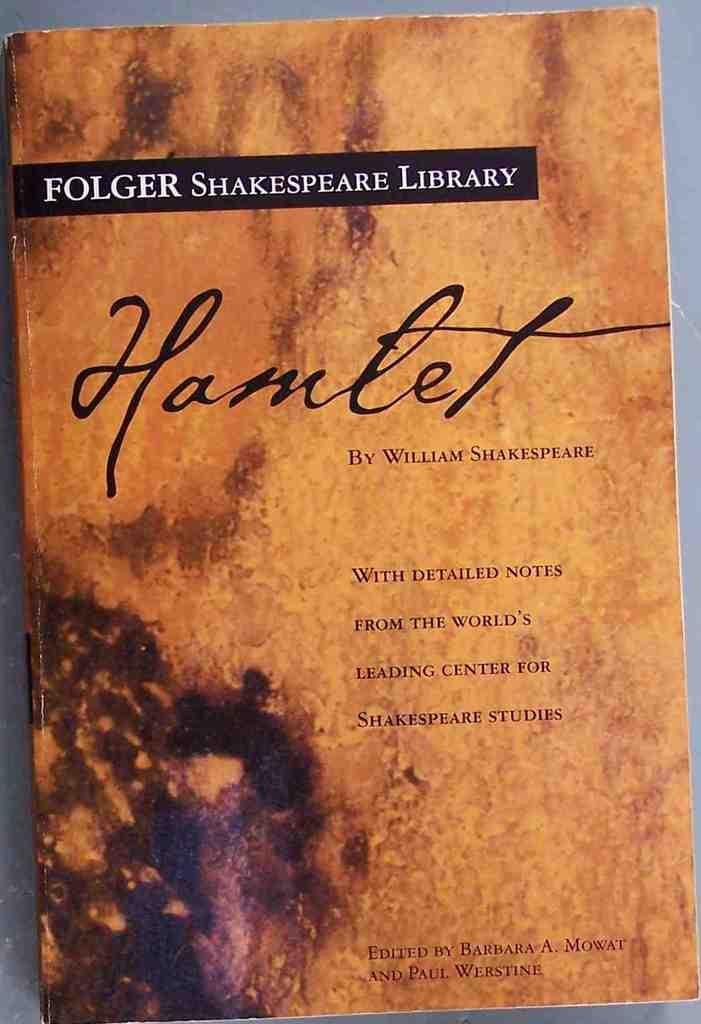<image>
Offer a succinct explanation of the picture presented. The Folger Shakespeare Library edition of the book Hamlet. 